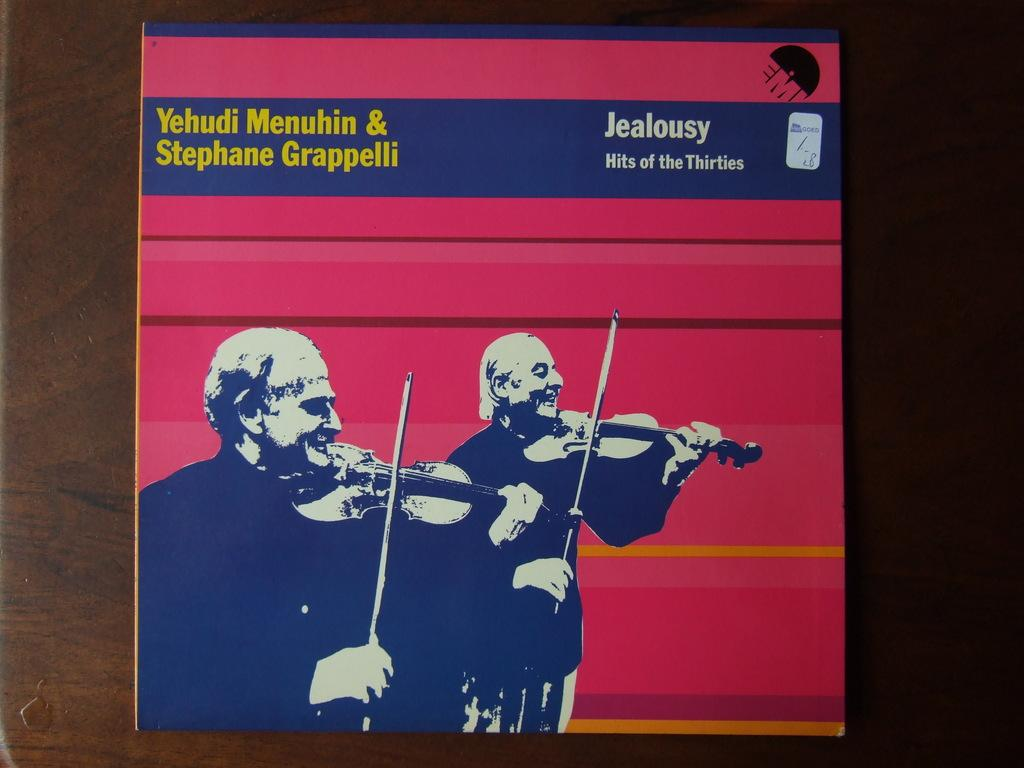Provide a one-sentence caption for the provided image. Album cover titled Jealousy showing two men playing violins. 